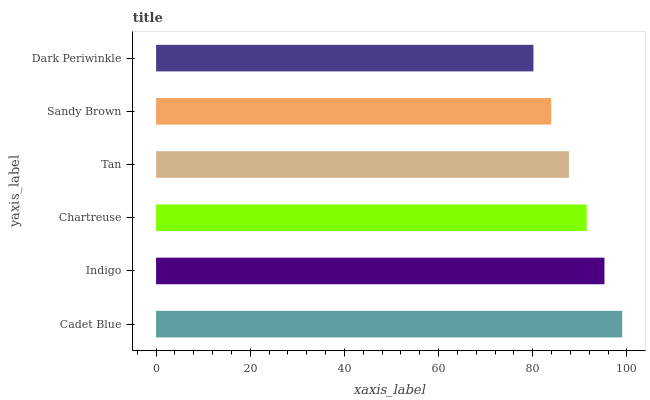Is Dark Periwinkle the minimum?
Answer yes or no. Yes. Is Cadet Blue the maximum?
Answer yes or no. Yes. Is Indigo the minimum?
Answer yes or no. No. Is Indigo the maximum?
Answer yes or no. No. Is Cadet Blue greater than Indigo?
Answer yes or no. Yes. Is Indigo less than Cadet Blue?
Answer yes or no. Yes. Is Indigo greater than Cadet Blue?
Answer yes or no. No. Is Cadet Blue less than Indigo?
Answer yes or no. No. Is Chartreuse the high median?
Answer yes or no. Yes. Is Tan the low median?
Answer yes or no. Yes. Is Sandy Brown the high median?
Answer yes or no. No. Is Dark Periwinkle the low median?
Answer yes or no. No. 